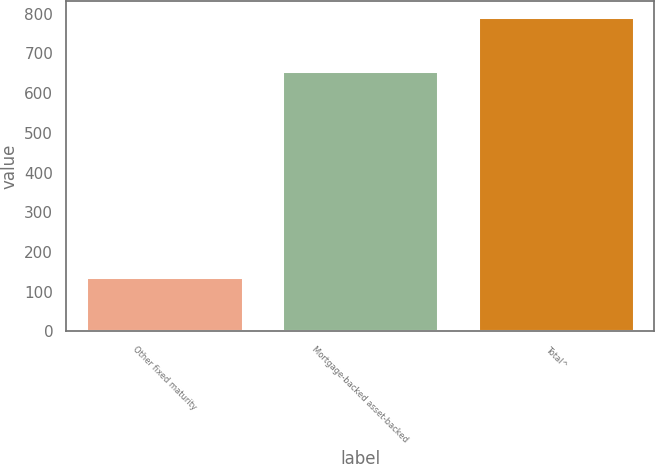<chart> <loc_0><loc_0><loc_500><loc_500><bar_chart><fcel>Other fixed maturity<fcel>Mortgage-backed asset-backed<fcel>Total^<nl><fcel>136<fcel>657<fcel>793<nl></chart> 